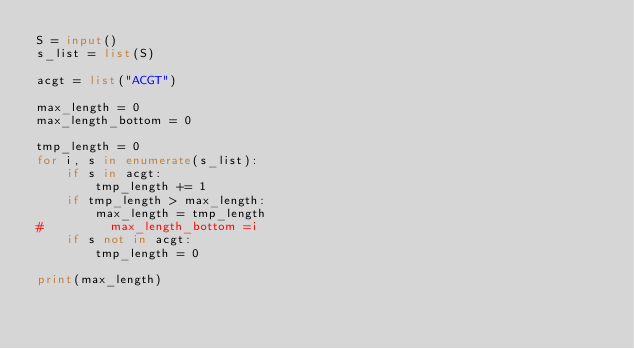<code> <loc_0><loc_0><loc_500><loc_500><_Python_>S = input()
s_list = list(S)

acgt = list("ACGT")

max_length = 0
max_length_bottom = 0

tmp_length = 0
for i, s in enumerate(s_list):
    if s in acgt:
        tmp_length += 1
    if tmp_length > max_length:
        max_length = tmp_length
#         max_length_bottom =i
    if s not in acgt:
        tmp_length = 0
        
print(max_length)</code> 